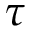Convert formula to latex. <formula><loc_0><loc_0><loc_500><loc_500>\tau</formula> 